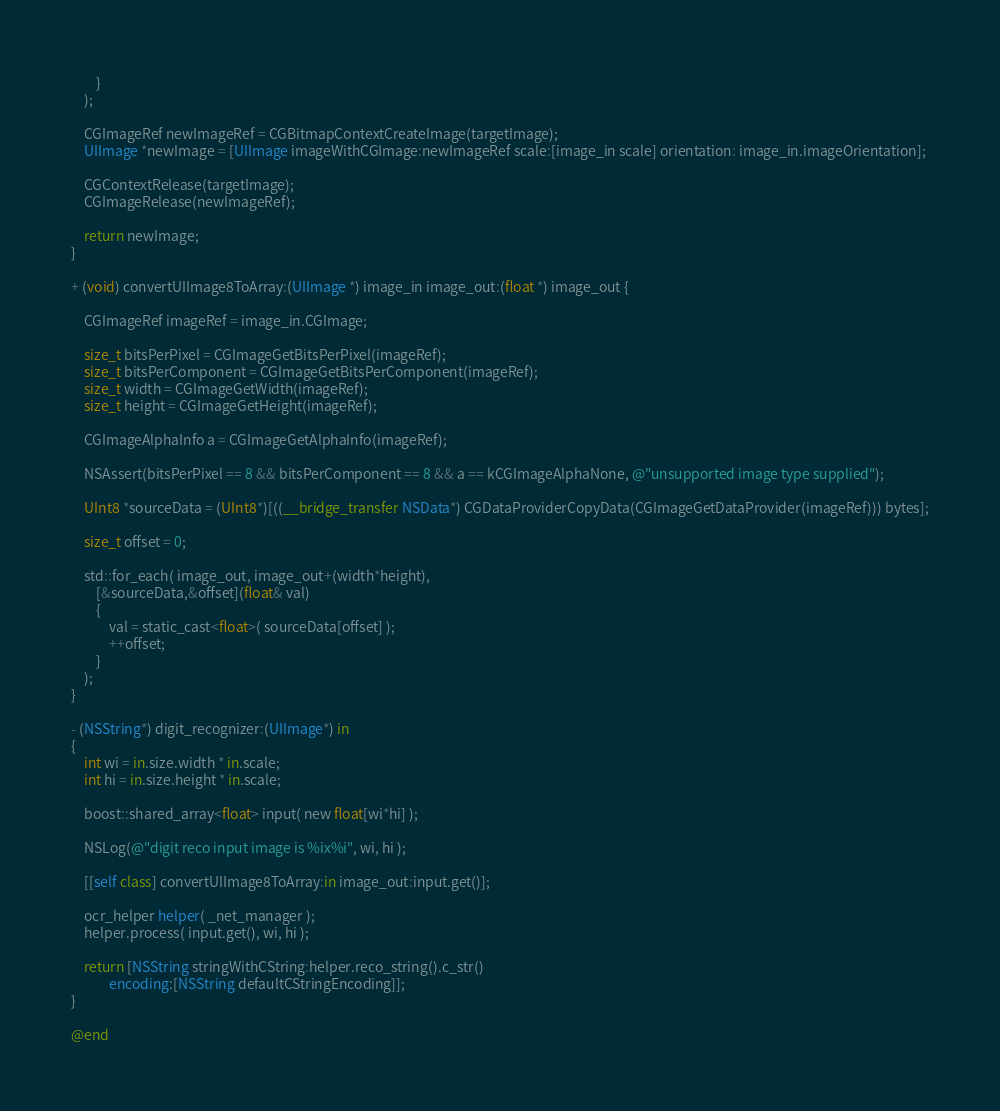Convert code to text. <code><loc_0><loc_0><loc_500><loc_500><_ObjectiveC_>        }
    );
    
    CGImageRef newImageRef = CGBitmapContextCreateImage(targetImage);
    UIImage *newImage = [UIImage imageWithCGImage:newImageRef scale:[image_in scale] orientation: image_in.imageOrientation];
    
    CGContextRelease(targetImage);
    CGImageRelease(newImageRef);
    
    return newImage;
}

+ (void) convertUIImage8ToArray:(UIImage *) image_in image_out:(float *) image_out {

    CGImageRef imageRef = image_in.CGImage;

    size_t bitsPerPixel = CGImageGetBitsPerPixel(imageRef);
    size_t bitsPerComponent = CGImageGetBitsPerComponent(imageRef);
    size_t width = CGImageGetWidth(imageRef);
    size_t height = CGImageGetHeight(imageRef);

    CGImageAlphaInfo a = CGImageGetAlphaInfo(imageRef);

    NSAssert(bitsPerPixel == 8 && bitsPerComponent == 8 && a == kCGImageAlphaNone, @"unsupported image type supplied");

    UInt8 *sourceData = (UInt8*)[((__bridge_transfer NSData*) CGDataProviderCopyData(CGImageGetDataProvider(imageRef))) bytes];

    size_t offset = 0;

    std::for_each( image_out, image_out+(width*height),
        [&sourceData,&offset](float& val)
        {
            val = static_cast<float>( sourceData[offset] );
            ++offset;
        }
    );
}

- (NSString*) digit_recognizer:(UIImage*) in
{
    int wi = in.size.width * in.scale;
    int hi = in.size.height * in.scale;

    boost::shared_array<float> input( new float[wi*hi] );

    NSLog(@"digit reco input image is %ix%i", wi, hi );

    [[self class] convertUIImage8ToArray:in image_out:input.get()];

    ocr_helper helper( _net_manager );
    helper.process( input.get(), wi, hi );

    return [NSString stringWithCString:helper.reco_string().c_str()
            encoding:[NSString defaultCStringEncoding]];
}

@end
</code> 